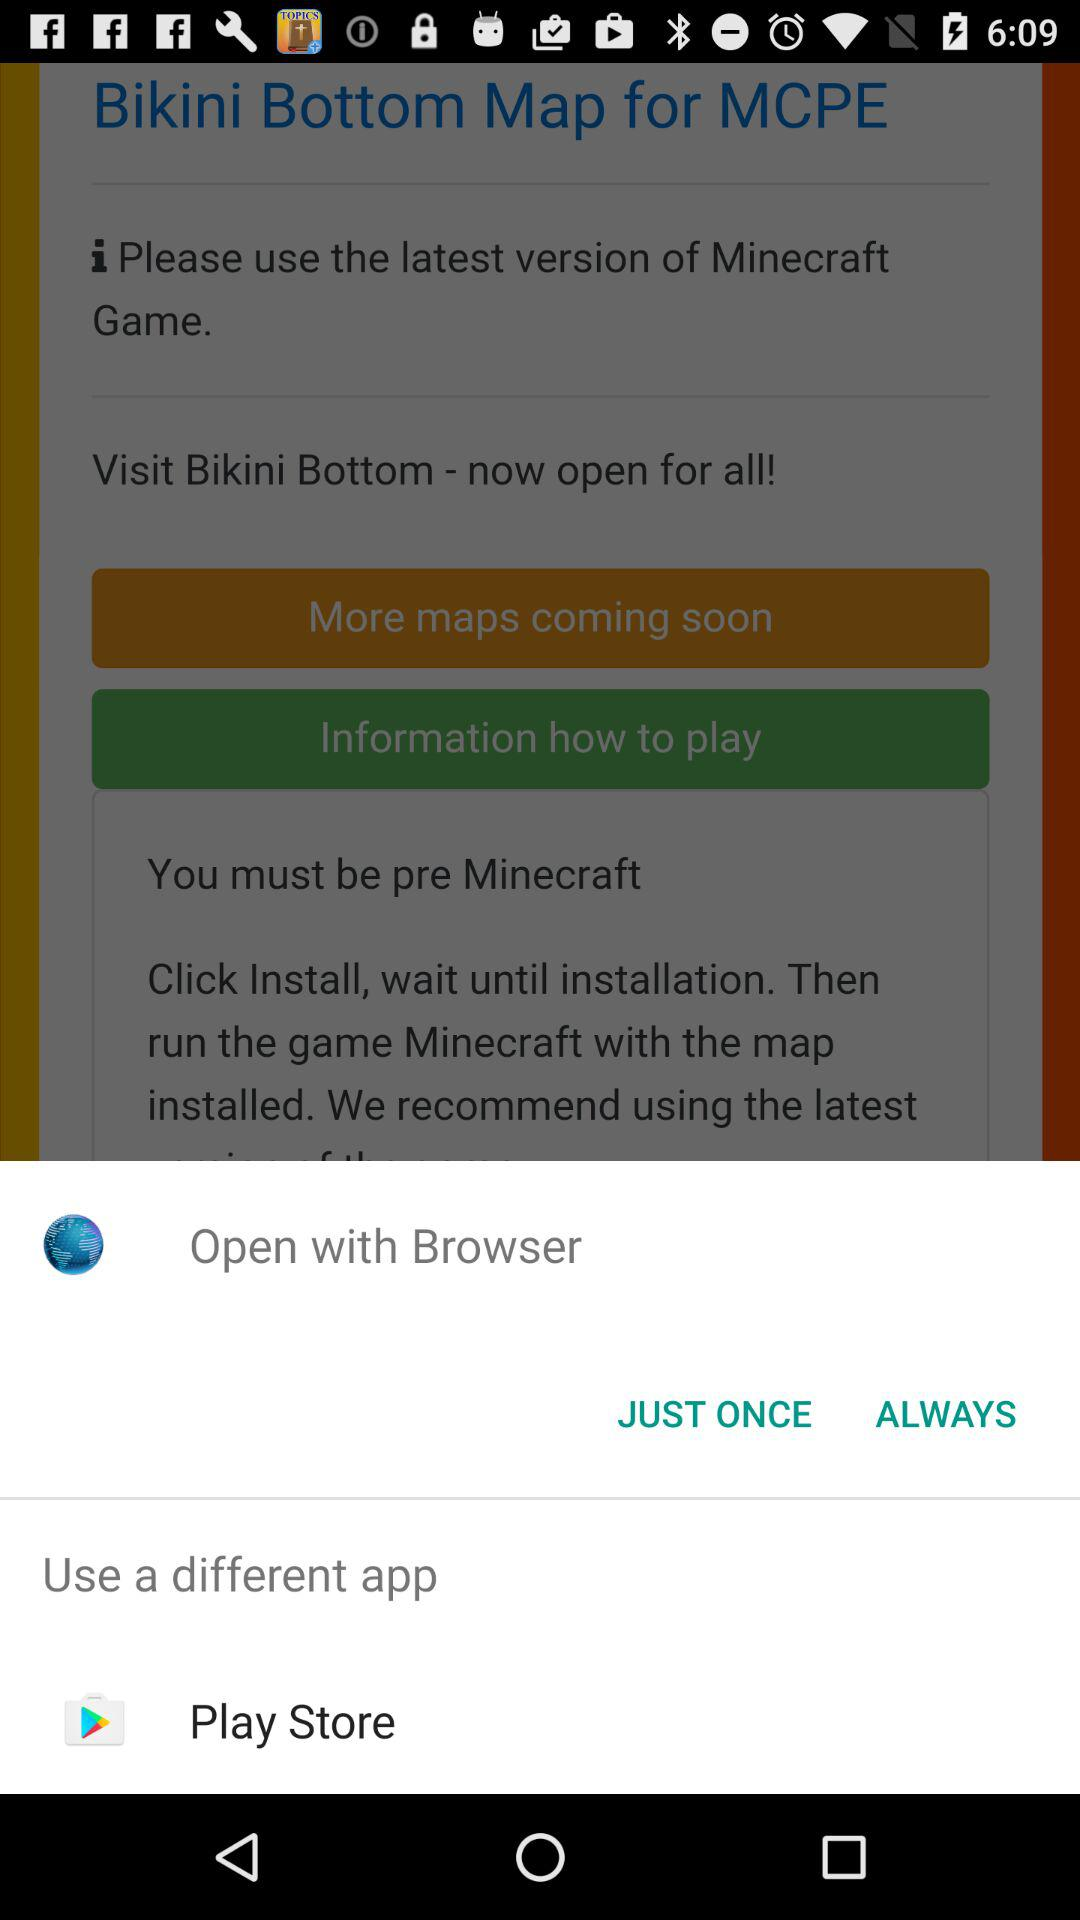From which app can we open the content? You can use "Browser" and "Play Store" to open the content. 